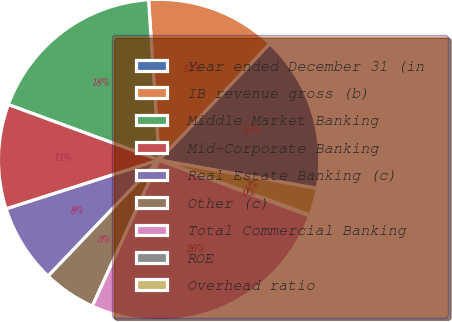<chart> <loc_0><loc_0><loc_500><loc_500><pie_chart><fcel>Year ended December 31 (in<fcel>IB revenue gross (b)<fcel>Middle Market Banking<fcel>Mid-Corporate Banking<fcel>Real Estate Banking (c)<fcel>Other (c)<fcel>Total Commercial Banking<fcel>ROE<fcel>Overhead ratio<nl><fcel>15.74%<fcel>13.14%<fcel>18.35%<fcel>10.53%<fcel>7.93%<fcel>5.32%<fcel>26.17%<fcel>0.11%<fcel>2.71%<nl></chart> 